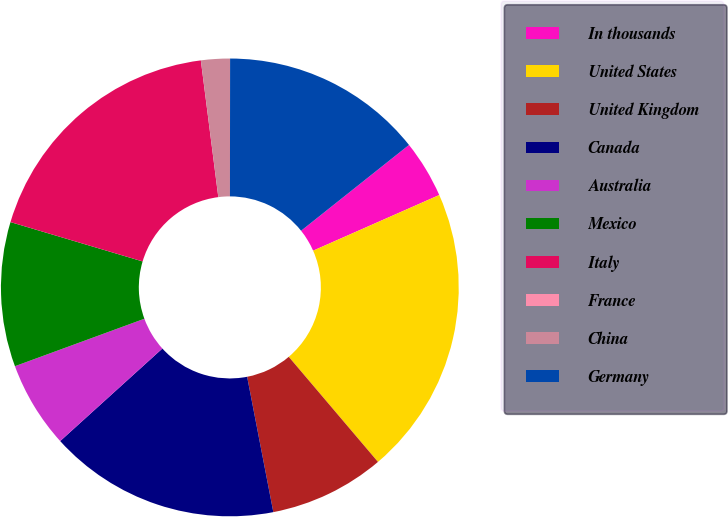Convert chart. <chart><loc_0><loc_0><loc_500><loc_500><pie_chart><fcel>In thousands<fcel>United States<fcel>United Kingdom<fcel>Canada<fcel>Australia<fcel>Mexico<fcel>Italy<fcel>France<fcel>China<fcel>Germany<nl><fcel>4.08%<fcel>20.41%<fcel>8.16%<fcel>16.33%<fcel>6.12%<fcel>10.2%<fcel>18.37%<fcel>0.0%<fcel>2.04%<fcel>14.29%<nl></chart> 